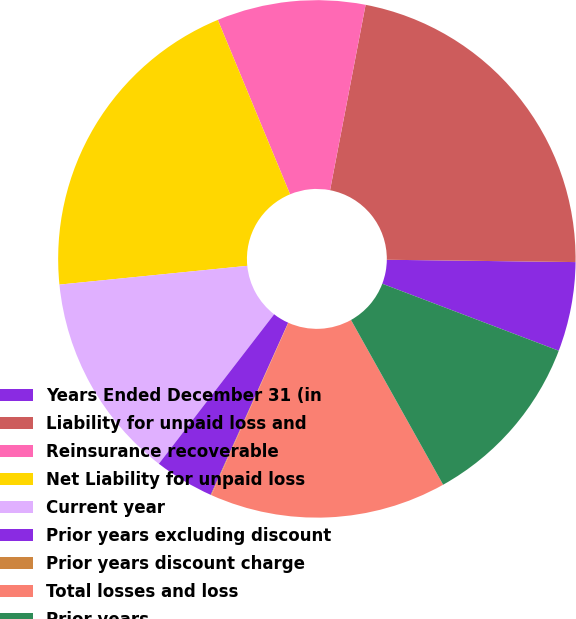Convert chart to OTSL. <chart><loc_0><loc_0><loc_500><loc_500><pie_chart><fcel>Years Ended December 31 (in<fcel>Liability for unpaid loss and<fcel>Reinsurance recoverable<fcel>Net Liability for unpaid loss<fcel>Current year<fcel>Prior years excluding discount<fcel>Prior years discount charge<fcel>Total losses and loss<fcel>Prior years<nl><fcel>5.58%<fcel>22.18%<fcel>9.27%<fcel>20.33%<fcel>12.96%<fcel>3.73%<fcel>0.04%<fcel>14.8%<fcel>11.11%<nl></chart> 